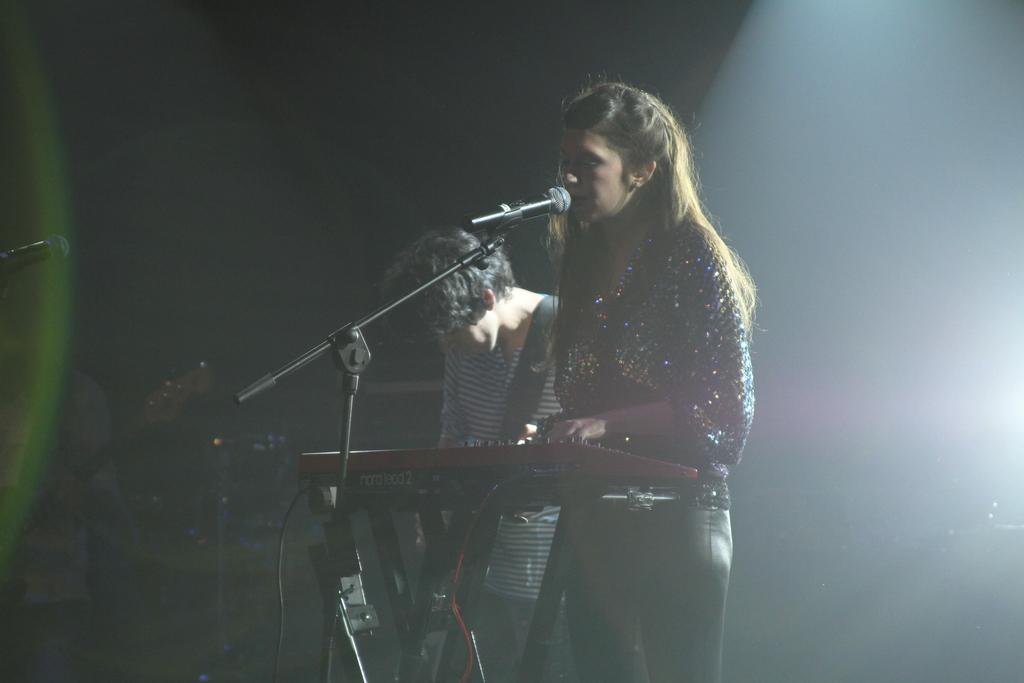How many people are in the image? There are two people in the image, a woman and a man. What are the woman and man doing in the image? The woman and man are standing in the image. What object is present that is typically used for amplifying sound? There is a microphone in the image. What type of object is present that is commonly used in music? There is a musical instrument in the image. What can be said about the lighting in the image? The background of the image is dark. What type of furniture can be seen in the image? There is no furniture present in the image. What type of vacation is the woman and man enjoying in the image? There is no indication of a vacation in the image; it appears to be a performance or event setting. 